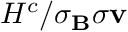<formula> <loc_0><loc_0><loc_500><loc_500>H ^ { c } / \sigma _ { B } \sigma { v }</formula> 